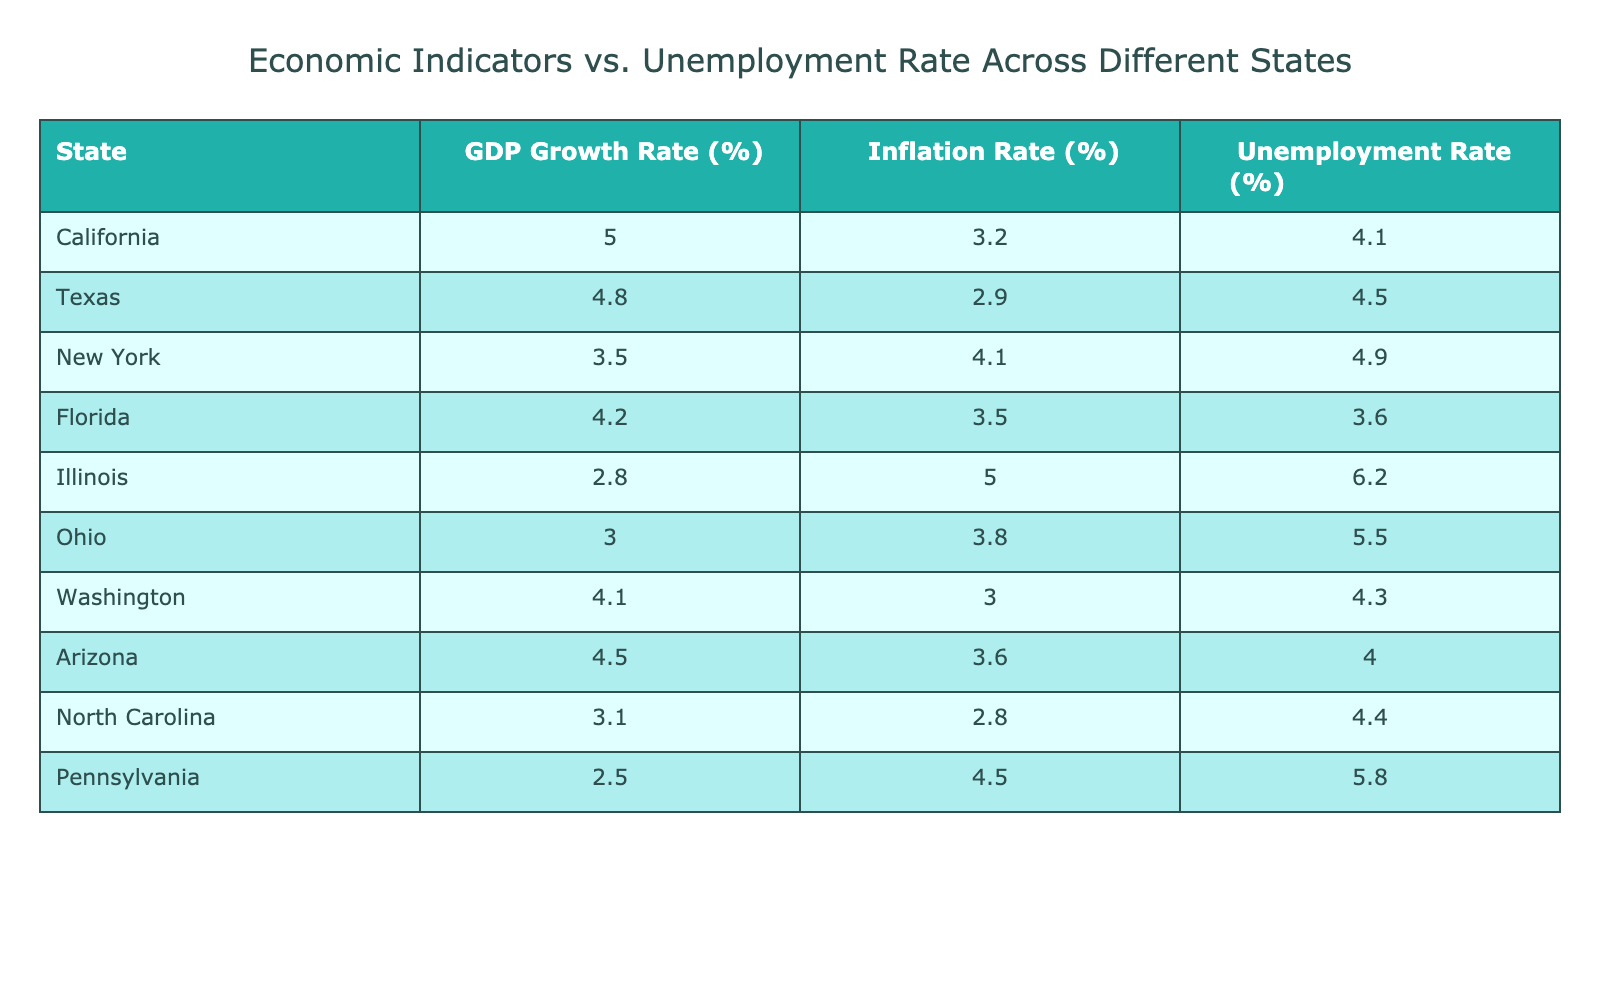What is the unemployment rate in Illinois? The table shows that the unemployment rate for Illinois is listed among the states. By looking at the row for Illinois, I see that the unemployment rate is 6.2%.
Answer: 6.2% Which state has the highest GDP growth rate? By scanning the GDP Growth Rate column in the table, I can identify the highest value. California has the highest GDP growth rate at 5.0%.
Answer: California What is the average unemployment rate across all states listed? To find the average, I first sum the unemployment rates for all states: 4.1 + 4.5 + 4.9 + 3.6 + 6.2 + 5.5 + 4.3 + 4.0 + 4.4 + 5.8 = 53.9. Then, I divide this sum by the number of states, which is 10: 53.9/10 = 5.39.
Answer: 5.39 Does Florida have an unemployment rate higher than the average? From the previous answer, the average unemployment rate is 5.39%. Looking at Florida's unemployment rate in the table, which is 3.6%, I find that 3.6% is less than 5.39%. Therefore, Florida does not have an unemployment rate higher than the average.
Answer: No If we compare the states with unemployment rates below 5%, how many states are there? First, I check the unemployment rates for each state. California (4.1%), Texas (4.5%), Florida (3.6%), and Arizona (4.0%) have rates below 5%. There are four states that meet this criterion.
Answer: 4 Which state has both the lowest GDP growth rate and the highest unemployment rate? I analyze the GDP Growth Rate column and identify that Pennsylvania has the lowest GDP growth rate at 2.5%. In the unemployment rate column, I see that Illinois has the highest unemployment rate at 6.2%. Since these states do not match, I conclude there isn't a single state meeting both criteria.
Answer: None Is the inflation rate in California lower than that in New York? The inflation rate for California is 3.2% and for New York, it is 4.1%. Since 3.2% is less than 4.1%, I can confirm that California's inflation rate is indeed lower than New York's.
Answer: Yes What is the difference in unemployment rates between the state with the highest and the lowest unemployment rates? The highest unemployment rate is in Illinois at 6.2%, and the lowest is in Florida at 3.6%. To find the difference, I subtract Florida's rate from Illinois' rate: 6.2 - 3.6 = 2.6.
Answer: 2.6 